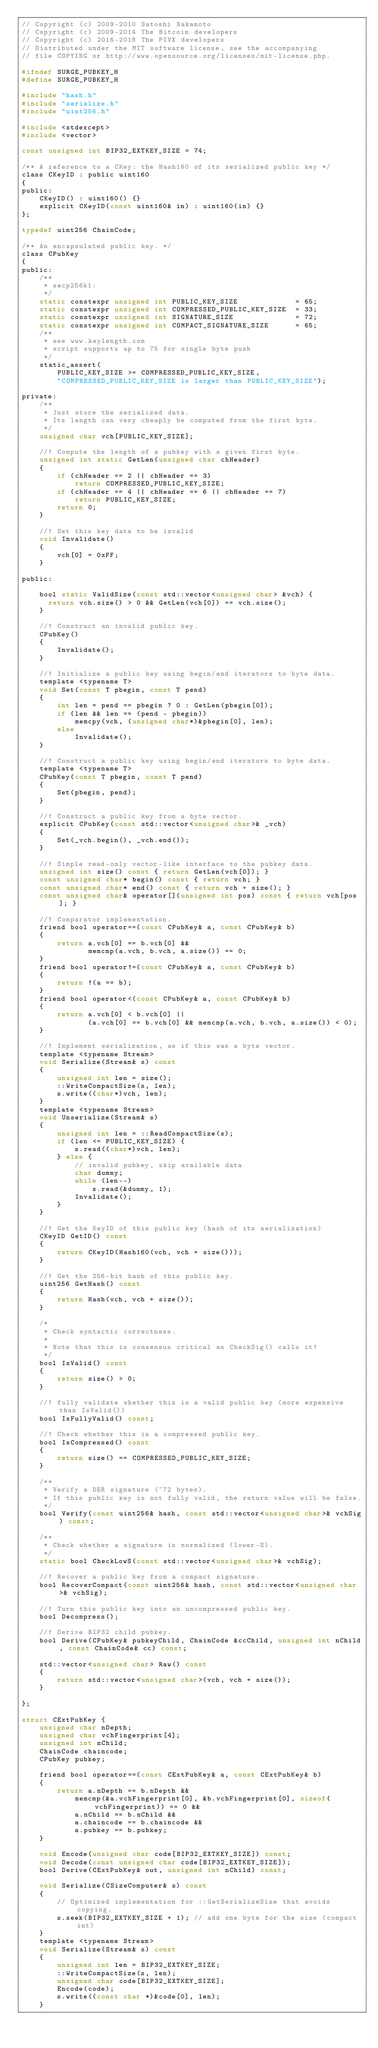<code> <loc_0><loc_0><loc_500><loc_500><_C_>// Copyright (c) 2009-2010 Satoshi Nakamoto
// Copyright (c) 2009-2014 The Bitcoin developers
// Copyright (c) 2016-2018 The PIVX developers
// Distributed under the MIT software license, see the accompanying
// file COPYING or http://www.opensource.org/licenses/mit-license.php.

#ifndef SURGE_PUBKEY_H
#define SURGE_PUBKEY_H

#include "hash.h"
#include "serialize.h"
#include "uint256.h"

#include <stdexcept>
#include <vector>

const unsigned int BIP32_EXTKEY_SIZE = 74;

/** A reference to a CKey: the Hash160 of its serialized public key */
class CKeyID : public uint160
{
public:
    CKeyID() : uint160() {}
    explicit CKeyID(const uint160& in) : uint160(in) {}
};

typedef uint256 ChainCode;

/** An encapsulated public key. */
class CPubKey
{
public:
    /**
     * secp256k1:
     */
    static constexpr unsigned int PUBLIC_KEY_SIZE             = 65;
    static constexpr unsigned int COMPRESSED_PUBLIC_KEY_SIZE  = 33;
    static constexpr unsigned int SIGNATURE_SIZE              = 72;
    static constexpr unsigned int COMPACT_SIGNATURE_SIZE      = 65;
    /**
     * see www.keylength.com
     * script supports up to 75 for single byte push
     */
    static_assert(
        PUBLIC_KEY_SIZE >= COMPRESSED_PUBLIC_KEY_SIZE,
        "COMPRESSED_PUBLIC_KEY_SIZE is larger than PUBLIC_KEY_SIZE");

private:
    /**
     * Just store the serialized data.
     * Its length can very cheaply be computed from the first byte.
     */
    unsigned char vch[PUBLIC_KEY_SIZE];

    //! Compute the length of a pubkey with a given first byte.
    unsigned int static GetLen(unsigned char chHeader)
    {
        if (chHeader == 2 || chHeader == 3)
            return COMPRESSED_PUBLIC_KEY_SIZE;
        if (chHeader == 4 || chHeader == 6 || chHeader == 7)
            return PUBLIC_KEY_SIZE;
        return 0;
    }

    //! Set this key data to be invalid
    void Invalidate()
    {
        vch[0] = 0xFF;
    }

public:

    bool static ValidSize(const std::vector<unsigned char> &vch) {
      return vch.size() > 0 && GetLen(vch[0]) == vch.size();
    }

    //! Construct an invalid public key.
    CPubKey()
    {
        Invalidate();
    }

    //! Initialize a public key using begin/end iterators to byte data.
    template <typename T>
    void Set(const T pbegin, const T pend)
    {
        int len = pend == pbegin ? 0 : GetLen(pbegin[0]);
        if (len && len == (pend - pbegin))
            memcpy(vch, (unsigned char*)&pbegin[0], len);
        else
            Invalidate();
    }

    //! Construct a public key using begin/end iterators to byte data.
    template <typename T>
    CPubKey(const T pbegin, const T pend)
    {
        Set(pbegin, pend);
    }

    //! Construct a public key from a byte vector.
    explicit CPubKey(const std::vector<unsigned char>& _vch)
    {
        Set(_vch.begin(), _vch.end());
    }

    //! Simple read-only vector-like interface to the pubkey data.
    unsigned int size() const { return GetLen(vch[0]); }
    const unsigned char* begin() const { return vch; }
    const unsigned char* end() const { return vch + size(); }
    const unsigned char& operator[](unsigned int pos) const { return vch[pos]; }

    //! Comparator implementation.
    friend bool operator==(const CPubKey& a, const CPubKey& b)
    {
        return a.vch[0] == b.vch[0] &&
               memcmp(a.vch, b.vch, a.size()) == 0;
    }
    friend bool operator!=(const CPubKey& a, const CPubKey& b)
    {
        return !(a == b);
    }
    friend bool operator<(const CPubKey& a, const CPubKey& b)
    {
        return a.vch[0] < b.vch[0] ||
               (a.vch[0] == b.vch[0] && memcmp(a.vch, b.vch, a.size()) < 0);
    }

    //! Implement serialization, as if this was a byte vector.
    template <typename Stream>
    void Serialize(Stream& s) const
    {
        unsigned int len = size();
        ::WriteCompactSize(s, len);
        s.write((char*)vch, len);
    }
    template <typename Stream>
    void Unserialize(Stream& s)
    {
        unsigned int len = ::ReadCompactSize(s);
        if (len <= PUBLIC_KEY_SIZE) {
            s.read((char*)vch, len);
        } else {
            // invalid pubkey, skip available data
            char dummy;
            while (len--)
                s.read(&dummy, 1);
            Invalidate();
        }
    }

    //! Get the KeyID of this public key (hash of its serialization)
    CKeyID GetID() const
    {
        return CKeyID(Hash160(vch, vch + size()));
    }

    //! Get the 256-bit hash of this public key.
    uint256 GetHash() const
    {
        return Hash(vch, vch + size());
    }

    /*
     * Check syntactic correctness.
     *
     * Note that this is consensus critical as CheckSig() calls it!
     */
    bool IsValid() const
    {
        return size() > 0;
    }

    //! fully validate whether this is a valid public key (more expensive than IsValid())
    bool IsFullyValid() const;

    //! Check whether this is a compressed public key.
    bool IsCompressed() const
    {
        return size() == COMPRESSED_PUBLIC_KEY_SIZE;
    }

    /**
     * Verify a DER signature (~72 bytes).
     * If this public key is not fully valid, the return value will be false.
     */
    bool Verify(const uint256& hash, const std::vector<unsigned char>& vchSig) const;

    /**
     * Check whether a signature is normalized (lower-S).
     */
    static bool CheckLowS(const std::vector<unsigned char>& vchSig);

    //! Recover a public key from a compact signature.
    bool RecoverCompact(const uint256& hash, const std::vector<unsigned char>& vchSig);

    //! Turn this public key into an uncompressed public key.
    bool Decompress();

    //! Derive BIP32 child pubkey.
    bool Derive(CPubKey& pubkeyChild, ChainCode &ccChild, unsigned int nChild, const ChainCode& cc) const;

    std::vector<unsigned char> Raw() const
    {
        return std::vector<unsigned char>(vch, vch + size());
    }

};

struct CExtPubKey {
    unsigned char nDepth;
    unsigned char vchFingerprint[4];
    unsigned int nChild;
    ChainCode chaincode;
    CPubKey pubkey;

    friend bool operator==(const CExtPubKey& a, const CExtPubKey& b)
    {
        return a.nDepth == b.nDepth &&
            memcmp(&a.vchFingerprint[0], &b.vchFingerprint[0], sizeof(vchFingerprint)) == 0 &&
            a.nChild == b.nChild &&
            a.chaincode == b.chaincode &&
            a.pubkey == b.pubkey;
    }

    void Encode(unsigned char code[BIP32_EXTKEY_SIZE]) const;
    void Decode(const unsigned char code[BIP32_EXTKEY_SIZE]);
    bool Derive(CExtPubKey& out, unsigned int nChild) const;

    void Serialize(CSizeComputer& s) const
    {
        // Optimized implementation for ::GetSerializeSize that avoids copying.
        s.seek(BIP32_EXTKEY_SIZE + 1); // add one byte for the size (compact int)
    }
    template <typename Stream>
    void Serialize(Stream& s) const
    {
        unsigned int len = BIP32_EXTKEY_SIZE;
        ::WriteCompactSize(s, len);
        unsigned char code[BIP32_EXTKEY_SIZE];
        Encode(code);
        s.write((const char *)&code[0], len);
    }</code> 